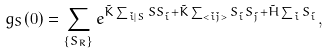<formula> <loc_0><loc_0><loc_500><loc_500>g _ { S } ( 0 ) = \sum _ { \{ S _ { R } \} } e ^ { \tilde { K } \sum _ { \tilde { i } | S } S S _ { \tilde { i } } + \tilde { K } \sum _ { < \tilde { i } \tilde { j } > } S _ { \tilde { i } } S _ { \tilde { j } } + \tilde { H } \sum _ { \tilde { i } } S _ { \tilde { i } } } ,</formula> 